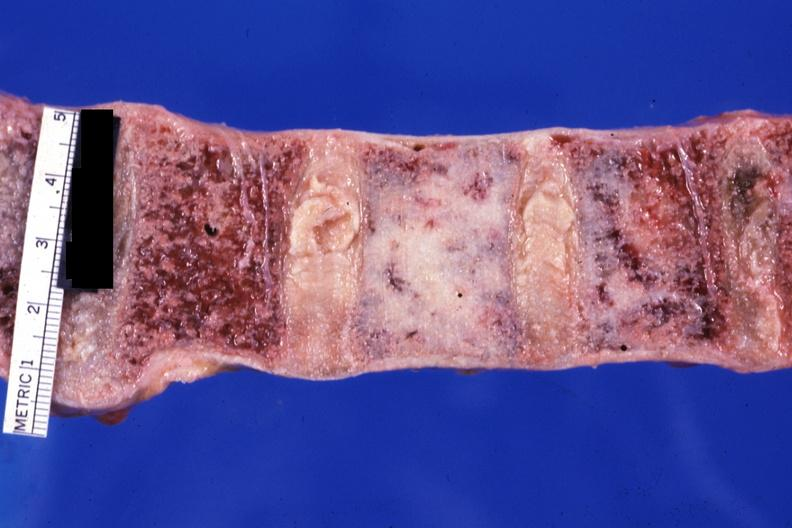what looks like ivory vertebra of breast carcinoma?
Answer the question using a single word or phrase. Close-up 